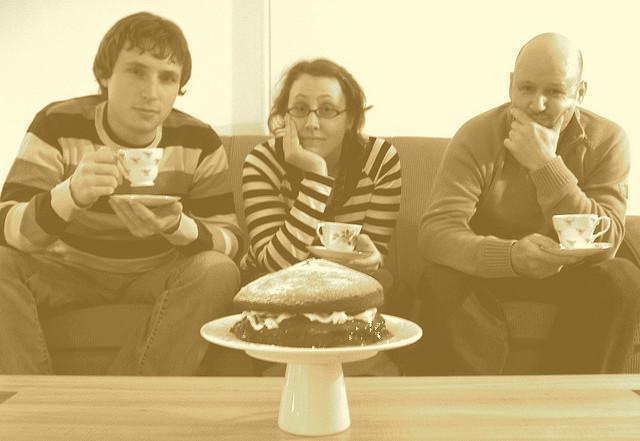How many people are there?
Give a very brief answer. 3. How many women?
Give a very brief answer. 1. How many sheep are standing?
Give a very brief answer. 0. 